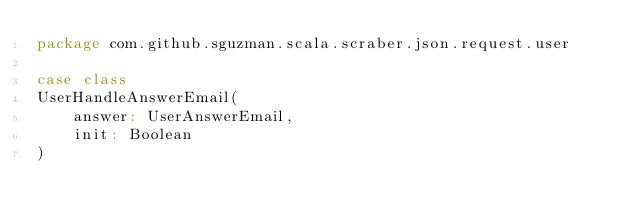Convert code to text. <code><loc_0><loc_0><loc_500><loc_500><_Scala_>package com.github.sguzman.scala.scraber.json.request.user

case class
UserHandleAnswerEmail(
    answer: UserAnswerEmail,
    init: Boolean
)
</code> 